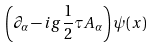Convert formula to latex. <formula><loc_0><loc_0><loc_500><loc_500>\left ( \partial _ { \alpha } - i g \frac { 1 } { 2 } \tau A _ { \alpha } \right ) \psi ( x )</formula> 